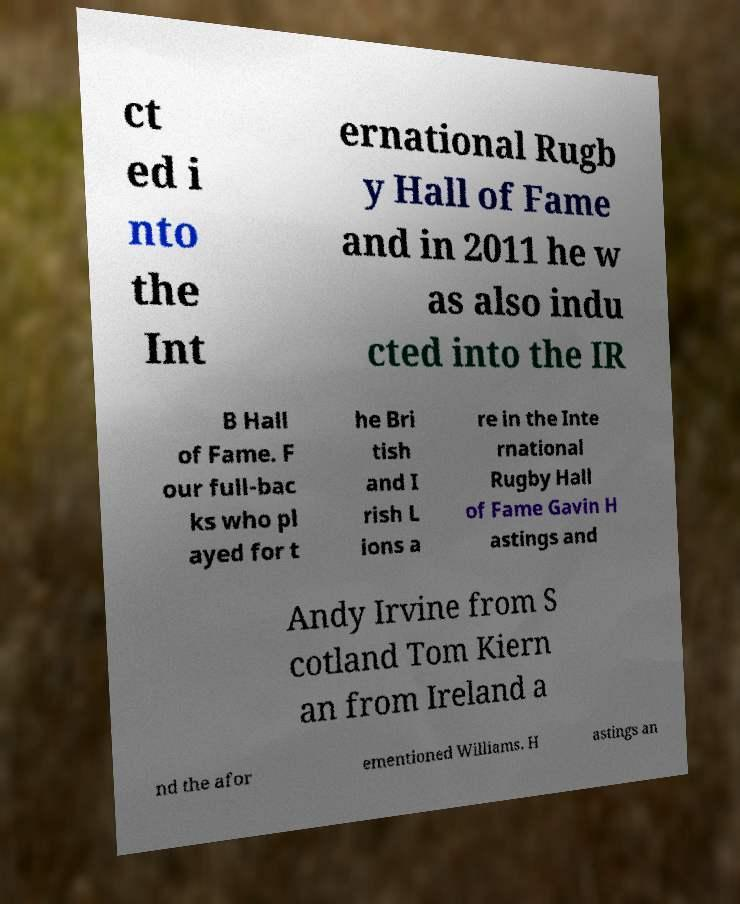There's text embedded in this image that I need extracted. Can you transcribe it verbatim? ct ed i nto the Int ernational Rugb y Hall of Fame and in 2011 he w as also indu cted into the IR B Hall of Fame. F our full-bac ks who pl ayed for t he Bri tish and I rish L ions a re in the Inte rnational Rugby Hall of Fame Gavin H astings and Andy Irvine from S cotland Tom Kiern an from Ireland a nd the afor ementioned Williams. H astings an 